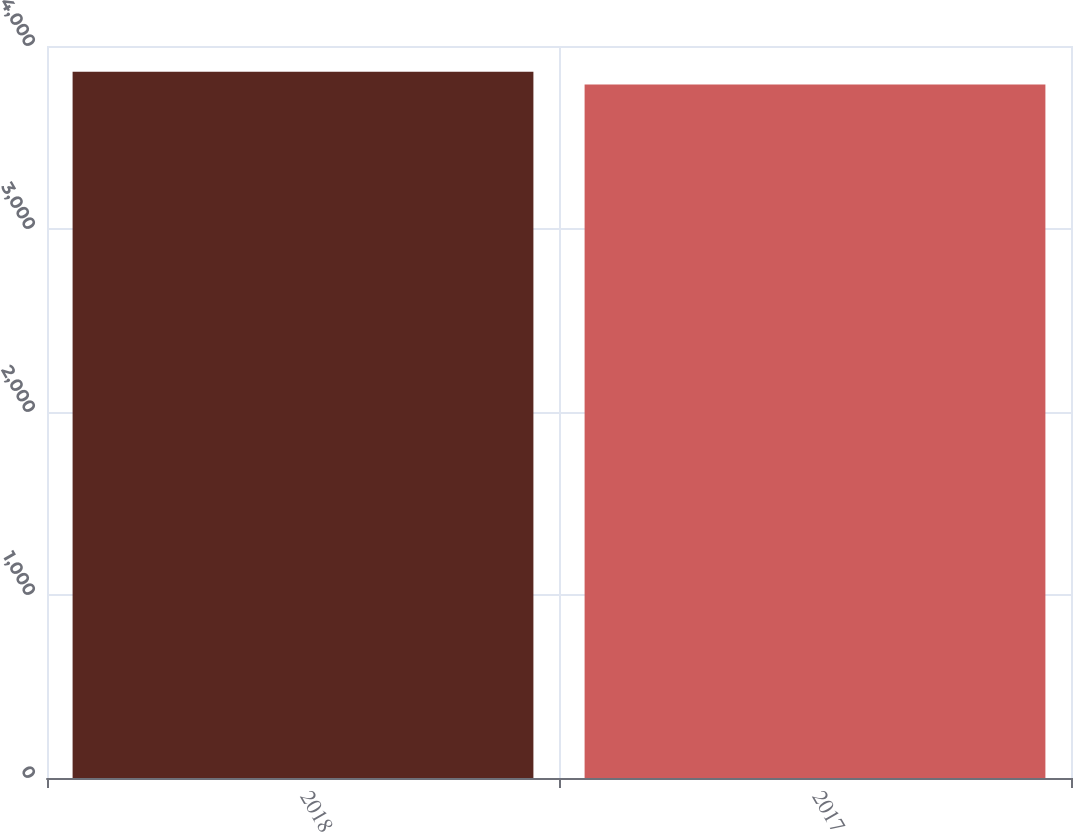<chart> <loc_0><loc_0><loc_500><loc_500><bar_chart><fcel>2018<fcel>2017<nl><fcel>3859.6<fcel>3790.1<nl></chart> 